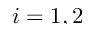<formula> <loc_0><loc_0><loc_500><loc_500>i = 1 , 2</formula> 